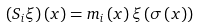<formula> <loc_0><loc_0><loc_500><loc_500>\left ( S _ { i } \xi \right ) \left ( x \right ) = m _ { i } \left ( x \right ) \xi \left ( \sigma \left ( x \right ) \right )</formula> 